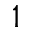Convert formula to latex. <formula><loc_0><loc_0><loc_500><loc_500>1</formula> 